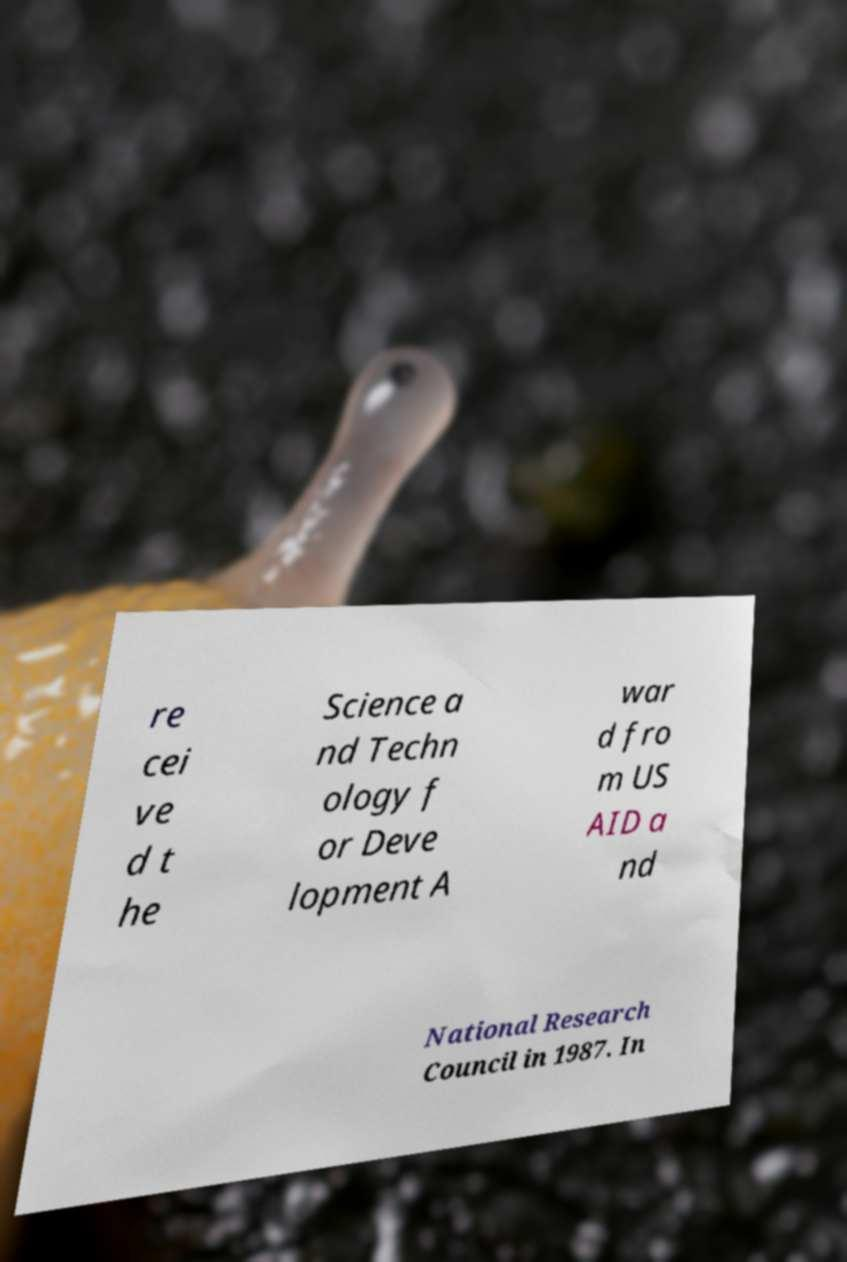Please identify and transcribe the text found in this image. re cei ve d t he Science a nd Techn ology f or Deve lopment A war d fro m US AID a nd National Research Council in 1987. In 